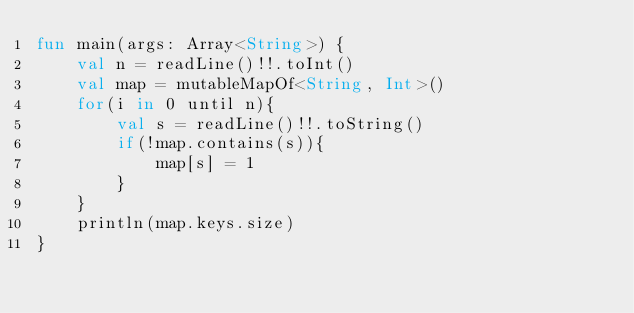<code> <loc_0><loc_0><loc_500><loc_500><_Kotlin_>fun main(args: Array<String>) {
    val n = readLine()!!.toInt()
    val map = mutableMapOf<String, Int>()
    for(i in 0 until n){
        val s = readLine()!!.toString()
        if(!map.contains(s)){
            map[s] = 1
        }
    }
    println(map.keys.size)
}</code> 